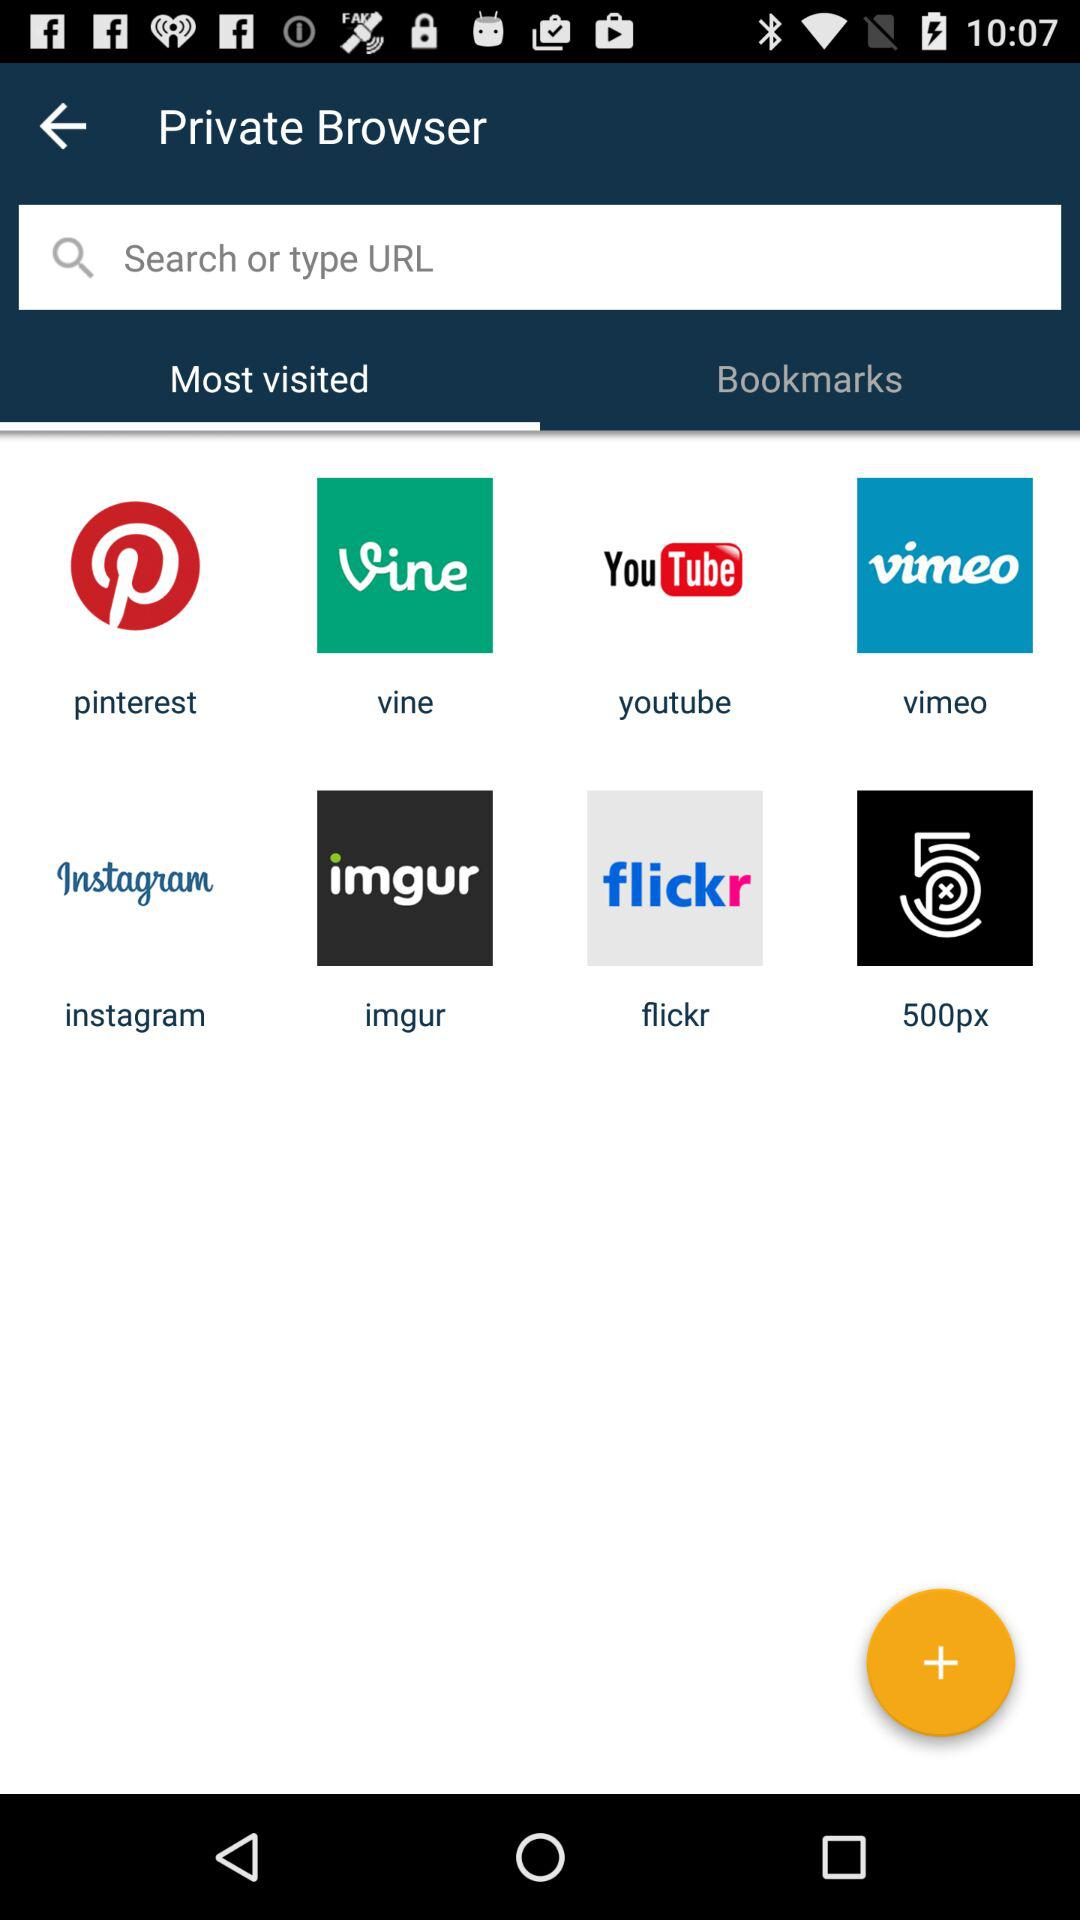Which tab is selected? The selected tab is "Most visited". 